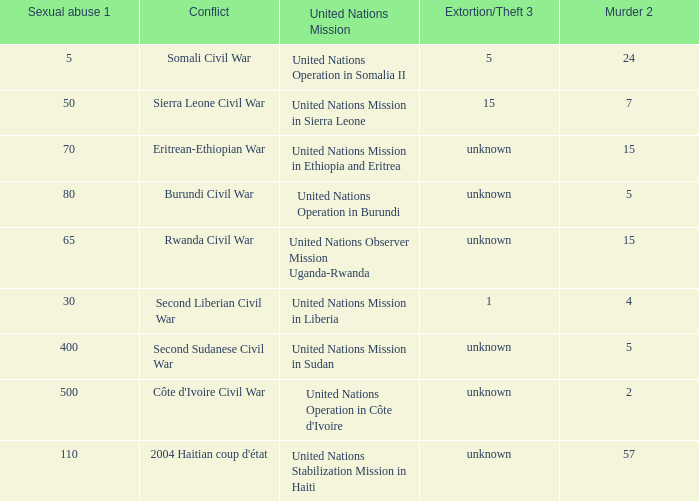What is the sexual abuse rate where the conflict is the Second Sudanese Civil War? 400.0. Give me the full table as a dictionary. {'header': ['Sexual abuse 1', 'Conflict', 'United Nations Mission', 'Extortion/Theft 3', 'Murder 2'], 'rows': [['5', 'Somali Civil War', 'United Nations Operation in Somalia II', '5', '24'], ['50', 'Sierra Leone Civil War', 'United Nations Mission in Sierra Leone', '15', '7'], ['70', 'Eritrean-Ethiopian War', 'United Nations Mission in Ethiopia and Eritrea', 'unknown', '15'], ['80', 'Burundi Civil War', 'United Nations Operation in Burundi', 'unknown', '5'], ['65', 'Rwanda Civil War', 'United Nations Observer Mission Uganda-Rwanda', 'unknown', '15'], ['30', 'Second Liberian Civil War', 'United Nations Mission in Liberia', '1', '4'], ['400', 'Second Sudanese Civil War', 'United Nations Mission in Sudan', 'unknown', '5'], ['500', "Côte d'Ivoire Civil War", "United Nations Operation in Côte d'Ivoire", 'unknown', '2'], ['110', "2004 Haitian coup d'état", 'United Nations Stabilization Mission in Haiti', 'unknown', '57']]} 